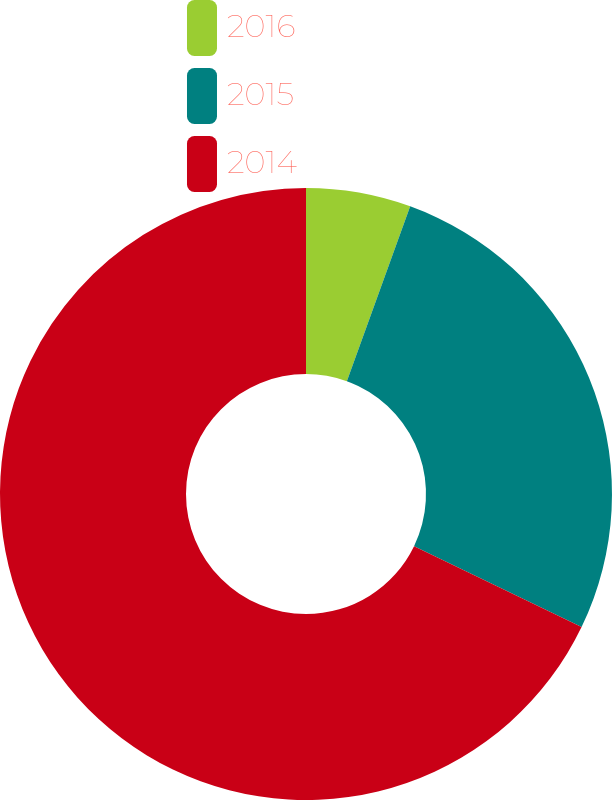<chart> <loc_0><loc_0><loc_500><loc_500><pie_chart><fcel>2016<fcel>2015<fcel>2014<nl><fcel>5.53%<fcel>26.63%<fcel>67.84%<nl></chart> 